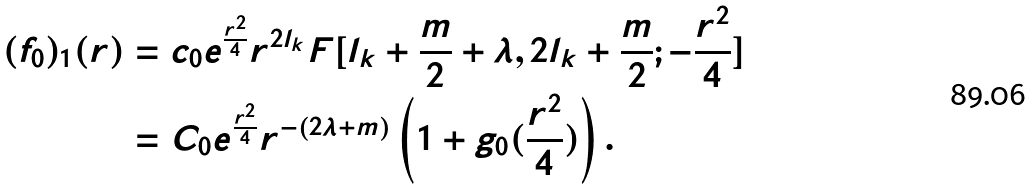Convert formula to latex. <formula><loc_0><loc_0><loc_500><loc_500>( f _ { 0 } ) _ { 1 } ( r ) & = c _ { 0 } e ^ { \frac { r ^ { 2 } } { 4 } } r ^ { 2 l _ { k } } F [ l _ { k } + \frac { m } { 2 } + \lambda , 2 l _ { k } + \frac { m } { 2 } ; - \frac { r ^ { 2 } } { 4 } ] \\ & = C _ { 0 } e ^ { \frac { r ^ { 2 } } { 4 } } r ^ { - ( 2 \lambda + m ) } \left ( 1 + g _ { 0 } ( \frac { r ^ { 2 } } { 4 } ) \right ) .</formula> 